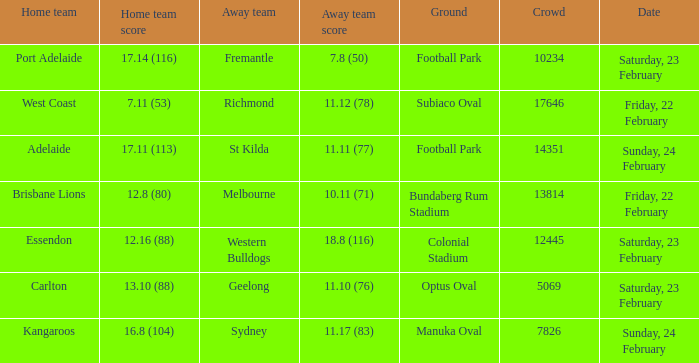On what date did the away team Fremantle play? Saturday, 23 February. 